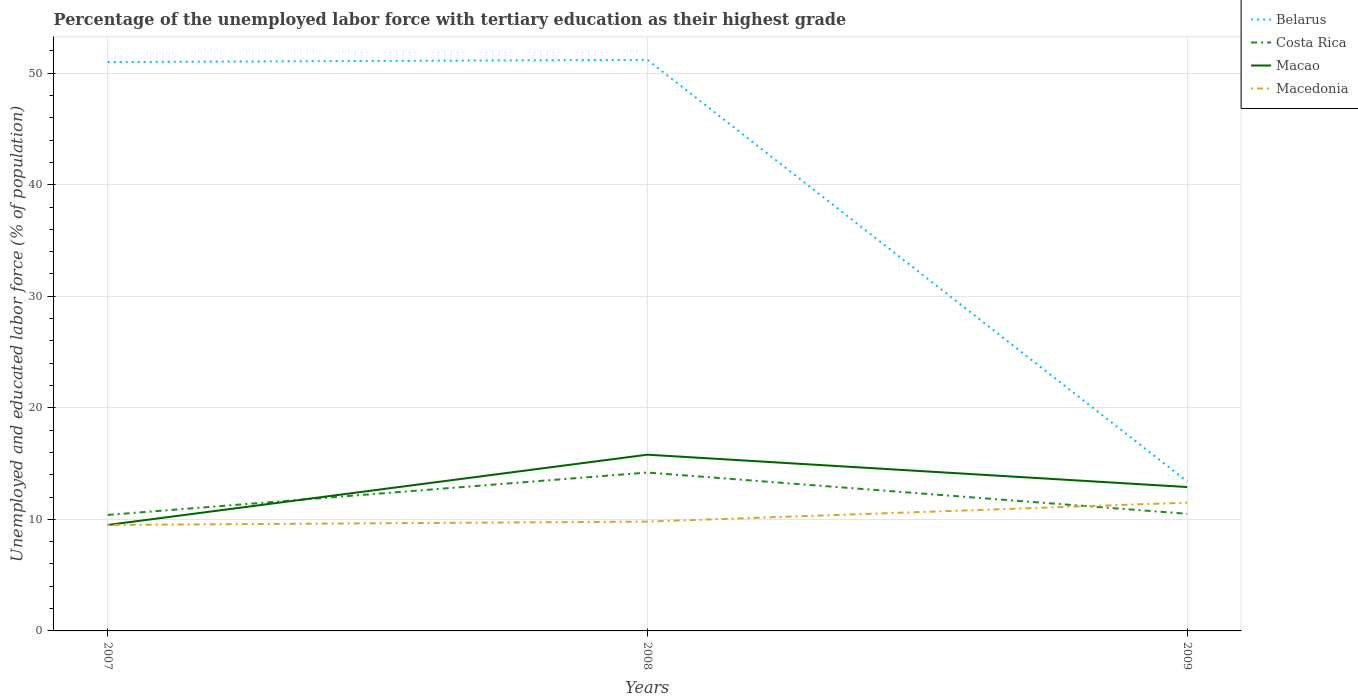How many different coloured lines are there?
Keep it short and to the point. 4. Does the line corresponding to Macedonia intersect with the line corresponding to Belarus?
Give a very brief answer. No. Is the number of lines equal to the number of legend labels?
Give a very brief answer. Yes. What is the total percentage of the unemployed labor force with tertiary education in Macedonia in the graph?
Keep it short and to the point. -0.3. What is the difference between the highest and the second highest percentage of the unemployed labor force with tertiary education in Belarus?
Your answer should be very brief. 37.8. What is the difference between the highest and the lowest percentage of the unemployed labor force with tertiary education in Macao?
Your answer should be compact. 2. How many lines are there?
Your answer should be compact. 4. Are the values on the major ticks of Y-axis written in scientific E-notation?
Give a very brief answer. No. Does the graph contain grids?
Make the answer very short. Yes. Where does the legend appear in the graph?
Provide a short and direct response. Top right. How many legend labels are there?
Offer a terse response. 4. How are the legend labels stacked?
Make the answer very short. Vertical. What is the title of the graph?
Keep it short and to the point. Percentage of the unemployed labor force with tertiary education as their highest grade. Does "Somalia" appear as one of the legend labels in the graph?
Your response must be concise. No. What is the label or title of the X-axis?
Make the answer very short. Years. What is the label or title of the Y-axis?
Ensure brevity in your answer.  Unemployed and educated labor force (% of population). What is the Unemployed and educated labor force (% of population) in Costa Rica in 2007?
Your response must be concise. 10.4. What is the Unemployed and educated labor force (% of population) of Macao in 2007?
Give a very brief answer. 9.5. What is the Unemployed and educated labor force (% of population) in Macedonia in 2007?
Keep it short and to the point. 9.5. What is the Unemployed and educated labor force (% of population) of Belarus in 2008?
Give a very brief answer. 51.2. What is the Unemployed and educated labor force (% of population) of Costa Rica in 2008?
Ensure brevity in your answer.  14.2. What is the Unemployed and educated labor force (% of population) of Macao in 2008?
Keep it short and to the point. 15.8. What is the Unemployed and educated labor force (% of population) in Macedonia in 2008?
Your response must be concise. 9.8. What is the Unemployed and educated labor force (% of population) of Belarus in 2009?
Your answer should be compact. 13.4. What is the Unemployed and educated labor force (% of population) in Macao in 2009?
Offer a terse response. 12.9. Across all years, what is the maximum Unemployed and educated labor force (% of population) of Belarus?
Ensure brevity in your answer.  51.2. Across all years, what is the maximum Unemployed and educated labor force (% of population) in Costa Rica?
Your answer should be very brief. 14.2. Across all years, what is the maximum Unemployed and educated labor force (% of population) in Macao?
Offer a terse response. 15.8. Across all years, what is the maximum Unemployed and educated labor force (% of population) in Macedonia?
Offer a very short reply. 11.5. Across all years, what is the minimum Unemployed and educated labor force (% of population) of Belarus?
Your answer should be compact. 13.4. Across all years, what is the minimum Unemployed and educated labor force (% of population) of Costa Rica?
Offer a very short reply. 10.4. Across all years, what is the minimum Unemployed and educated labor force (% of population) in Macao?
Provide a succinct answer. 9.5. What is the total Unemployed and educated labor force (% of population) in Belarus in the graph?
Your answer should be very brief. 115.6. What is the total Unemployed and educated labor force (% of population) of Costa Rica in the graph?
Your answer should be compact. 35.1. What is the total Unemployed and educated labor force (% of population) of Macao in the graph?
Your response must be concise. 38.2. What is the total Unemployed and educated labor force (% of population) in Macedonia in the graph?
Keep it short and to the point. 30.8. What is the difference between the Unemployed and educated labor force (% of population) in Belarus in 2007 and that in 2008?
Offer a terse response. -0.2. What is the difference between the Unemployed and educated labor force (% of population) of Costa Rica in 2007 and that in 2008?
Provide a short and direct response. -3.8. What is the difference between the Unemployed and educated labor force (% of population) of Macao in 2007 and that in 2008?
Your answer should be very brief. -6.3. What is the difference between the Unemployed and educated labor force (% of population) of Macedonia in 2007 and that in 2008?
Offer a very short reply. -0.3. What is the difference between the Unemployed and educated labor force (% of population) in Belarus in 2007 and that in 2009?
Offer a terse response. 37.6. What is the difference between the Unemployed and educated labor force (% of population) in Costa Rica in 2007 and that in 2009?
Ensure brevity in your answer.  -0.1. What is the difference between the Unemployed and educated labor force (% of population) in Belarus in 2008 and that in 2009?
Make the answer very short. 37.8. What is the difference between the Unemployed and educated labor force (% of population) of Macao in 2008 and that in 2009?
Offer a terse response. 2.9. What is the difference between the Unemployed and educated labor force (% of population) in Belarus in 2007 and the Unemployed and educated labor force (% of population) in Costa Rica in 2008?
Your answer should be very brief. 36.8. What is the difference between the Unemployed and educated labor force (% of population) in Belarus in 2007 and the Unemployed and educated labor force (% of population) in Macao in 2008?
Give a very brief answer. 35.2. What is the difference between the Unemployed and educated labor force (% of population) in Belarus in 2007 and the Unemployed and educated labor force (% of population) in Macedonia in 2008?
Keep it short and to the point. 41.2. What is the difference between the Unemployed and educated labor force (% of population) of Costa Rica in 2007 and the Unemployed and educated labor force (% of population) of Macao in 2008?
Make the answer very short. -5.4. What is the difference between the Unemployed and educated labor force (% of population) of Macao in 2007 and the Unemployed and educated labor force (% of population) of Macedonia in 2008?
Your answer should be very brief. -0.3. What is the difference between the Unemployed and educated labor force (% of population) in Belarus in 2007 and the Unemployed and educated labor force (% of population) in Costa Rica in 2009?
Make the answer very short. 40.5. What is the difference between the Unemployed and educated labor force (% of population) of Belarus in 2007 and the Unemployed and educated labor force (% of population) of Macao in 2009?
Offer a terse response. 38.1. What is the difference between the Unemployed and educated labor force (% of population) in Belarus in 2007 and the Unemployed and educated labor force (% of population) in Macedonia in 2009?
Your response must be concise. 39.5. What is the difference between the Unemployed and educated labor force (% of population) in Macao in 2007 and the Unemployed and educated labor force (% of population) in Macedonia in 2009?
Your answer should be compact. -2. What is the difference between the Unemployed and educated labor force (% of population) of Belarus in 2008 and the Unemployed and educated labor force (% of population) of Costa Rica in 2009?
Give a very brief answer. 40.7. What is the difference between the Unemployed and educated labor force (% of population) of Belarus in 2008 and the Unemployed and educated labor force (% of population) of Macao in 2009?
Offer a terse response. 38.3. What is the difference between the Unemployed and educated labor force (% of population) of Belarus in 2008 and the Unemployed and educated labor force (% of population) of Macedonia in 2009?
Give a very brief answer. 39.7. What is the difference between the Unemployed and educated labor force (% of population) in Costa Rica in 2008 and the Unemployed and educated labor force (% of population) in Macao in 2009?
Your answer should be very brief. 1.3. What is the difference between the Unemployed and educated labor force (% of population) of Macao in 2008 and the Unemployed and educated labor force (% of population) of Macedonia in 2009?
Your answer should be compact. 4.3. What is the average Unemployed and educated labor force (% of population) of Belarus per year?
Ensure brevity in your answer.  38.53. What is the average Unemployed and educated labor force (% of population) in Costa Rica per year?
Give a very brief answer. 11.7. What is the average Unemployed and educated labor force (% of population) of Macao per year?
Ensure brevity in your answer.  12.73. What is the average Unemployed and educated labor force (% of population) in Macedonia per year?
Provide a short and direct response. 10.27. In the year 2007, what is the difference between the Unemployed and educated labor force (% of population) of Belarus and Unemployed and educated labor force (% of population) of Costa Rica?
Give a very brief answer. 40.6. In the year 2007, what is the difference between the Unemployed and educated labor force (% of population) of Belarus and Unemployed and educated labor force (% of population) of Macao?
Ensure brevity in your answer.  41.5. In the year 2007, what is the difference between the Unemployed and educated labor force (% of population) in Belarus and Unemployed and educated labor force (% of population) in Macedonia?
Your response must be concise. 41.5. In the year 2008, what is the difference between the Unemployed and educated labor force (% of population) in Belarus and Unemployed and educated labor force (% of population) in Costa Rica?
Provide a short and direct response. 37. In the year 2008, what is the difference between the Unemployed and educated labor force (% of population) in Belarus and Unemployed and educated labor force (% of population) in Macao?
Your answer should be very brief. 35.4. In the year 2008, what is the difference between the Unemployed and educated labor force (% of population) in Belarus and Unemployed and educated labor force (% of population) in Macedonia?
Provide a short and direct response. 41.4. In the year 2008, what is the difference between the Unemployed and educated labor force (% of population) in Costa Rica and Unemployed and educated labor force (% of population) in Macao?
Offer a terse response. -1.6. In the year 2008, what is the difference between the Unemployed and educated labor force (% of population) of Costa Rica and Unemployed and educated labor force (% of population) of Macedonia?
Give a very brief answer. 4.4. In the year 2008, what is the difference between the Unemployed and educated labor force (% of population) of Macao and Unemployed and educated labor force (% of population) of Macedonia?
Offer a terse response. 6. In the year 2009, what is the difference between the Unemployed and educated labor force (% of population) in Belarus and Unemployed and educated labor force (% of population) in Macedonia?
Provide a short and direct response. 1.9. In the year 2009, what is the difference between the Unemployed and educated labor force (% of population) of Costa Rica and Unemployed and educated labor force (% of population) of Macedonia?
Give a very brief answer. -1. In the year 2009, what is the difference between the Unemployed and educated labor force (% of population) in Macao and Unemployed and educated labor force (% of population) in Macedonia?
Offer a very short reply. 1.4. What is the ratio of the Unemployed and educated labor force (% of population) in Costa Rica in 2007 to that in 2008?
Keep it short and to the point. 0.73. What is the ratio of the Unemployed and educated labor force (% of population) in Macao in 2007 to that in 2008?
Provide a short and direct response. 0.6. What is the ratio of the Unemployed and educated labor force (% of population) of Macedonia in 2007 to that in 2008?
Make the answer very short. 0.97. What is the ratio of the Unemployed and educated labor force (% of population) in Belarus in 2007 to that in 2009?
Provide a short and direct response. 3.81. What is the ratio of the Unemployed and educated labor force (% of population) of Macao in 2007 to that in 2009?
Provide a short and direct response. 0.74. What is the ratio of the Unemployed and educated labor force (% of population) of Macedonia in 2007 to that in 2009?
Offer a terse response. 0.83. What is the ratio of the Unemployed and educated labor force (% of population) of Belarus in 2008 to that in 2009?
Offer a terse response. 3.82. What is the ratio of the Unemployed and educated labor force (% of population) of Costa Rica in 2008 to that in 2009?
Give a very brief answer. 1.35. What is the ratio of the Unemployed and educated labor force (% of population) in Macao in 2008 to that in 2009?
Your response must be concise. 1.22. What is the ratio of the Unemployed and educated labor force (% of population) of Macedonia in 2008 to that in 2009?
Your response must be concise. 0.85. What is the difference between the highest and the second highest Unemployed and educated labor force (% of population) of Macao?
Your answer should be compact. 2.9. What is the difference between the highest and the lowest Unemployed and educated labor force (% of population) in Belarus?
Give a very brief answer. 37.8. What is the difference between the highest and the lowest Unemployed and educated labor force (% of population) of Macao?
Your response must be concise. 6.3. 